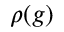<formula> <loc_0><loc_0><loc_500><loc_500>\rho ( g )</formula> 